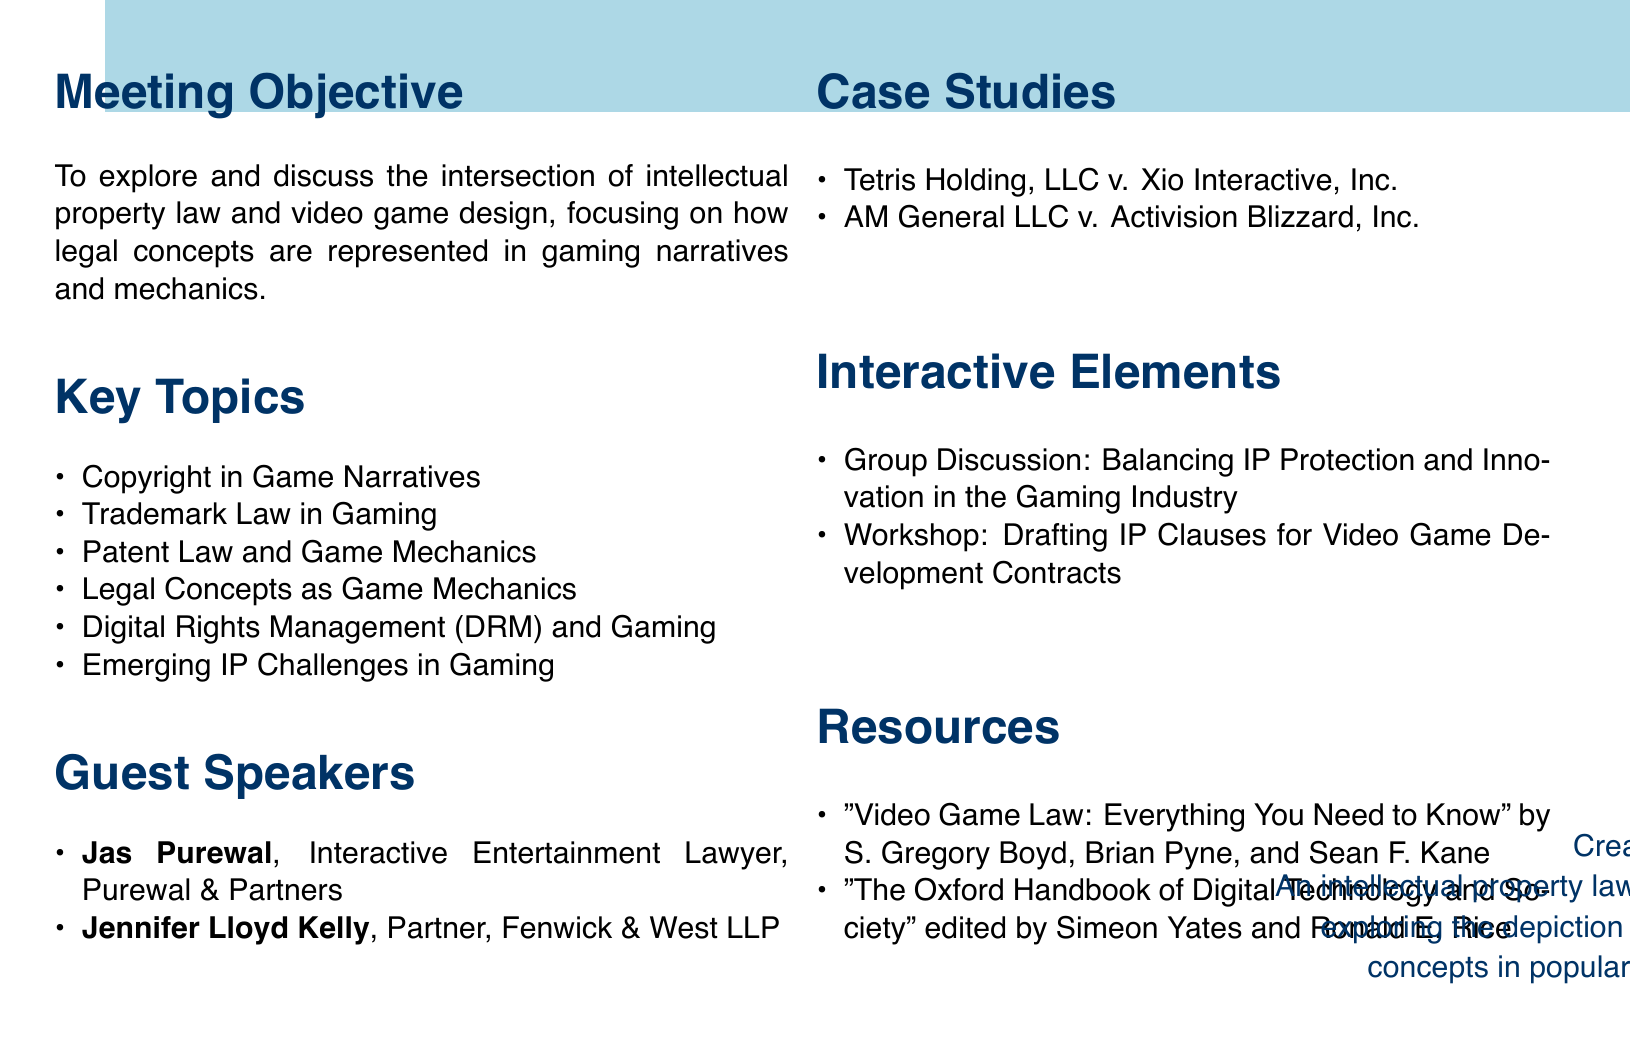What is the meeting title? The meeting title is the main topic discussed in the document.
Answer: Video Game IP: Analyzing Legal Concepts in Gaming Narratives and Mechanics Who is the first guest speaker? The first guest speaker is listed under the guest speakers section of the document.
Answer: Jas Purewal What is the focus of the first key topic? The first key topic addresses a specific aspect of intellectual property law related to video games.
Answer: Copyright in Game Narratives How many case studies are presented? The number of case studies can be found in the case studies section of the document.
Answer: 2 What is the topic of the workshop in interactive elements? The workshop topic is detailed in the interactive elements section of the document.
Answer: Drafting IP Clauses for Video Game Development Contracts Which book discusses digital games and IP law? The relevant resource title addresses the connection between digital games and intellectual property law.
Answer: The Oxford Handbook of Digital Technology and Society What is the relationship between IP protection and innovation discussed in the interactive elements? The relevance of IP protection and innovation is mentioned as a discussion topic in the document.
Answer: Balancing IP Protection and Innovation in the Gaming Industry What year was the resource published? The publication year can be found in the resources section of the document for each listed source.
Answer: 2019 